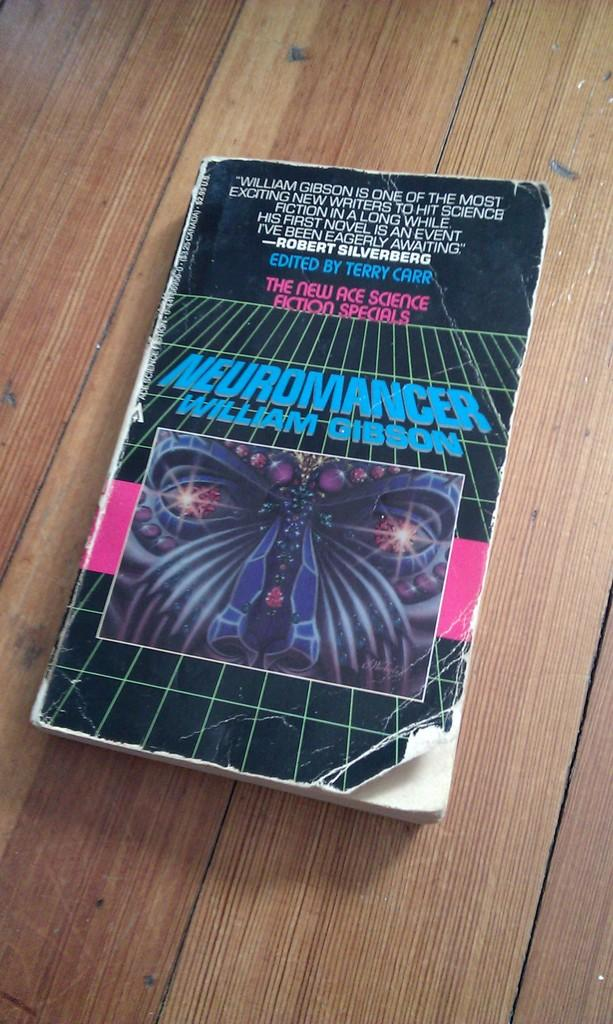<image>
Relay a brief, clear account of the picture shown. Old worn copy of Neuromancer book is on the wooden table. 